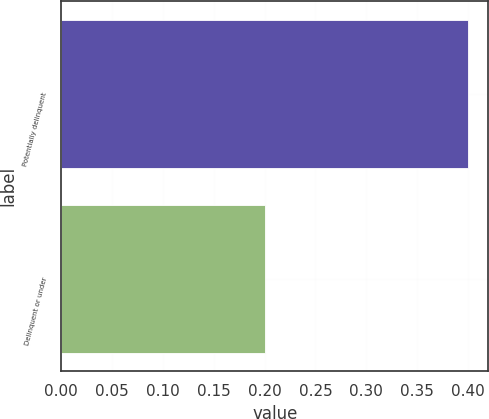<chart> <loc_0><loc_0><loc_500><loc_500><bar_chart><fcel>Potentially delinquent<fcel>Delinquent or under<nl><fcel>0.4<fcel>0.2<nl></chart> 